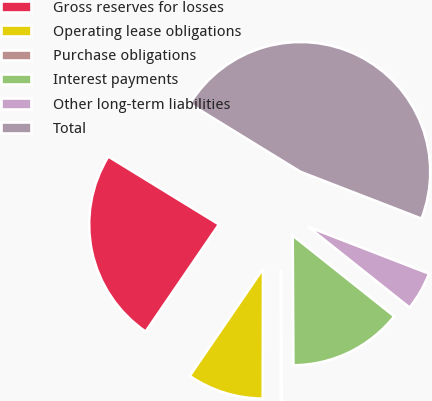<chart> <loc_0><loc_0><loc_500><loc_500><pie_chart><fcel>Gross reserves for losses<fcel>Operating lease obligations<fcel>Purchase obligations<fcel>Interest payments<fcel>Other long-term liabilities<fcel>Total<nl><fcel>24.22%<fcel>9.52%<fcel>0.12%<fcel>14.22%<fcel>4.82%<fcel>47.12%<nl></chart> 